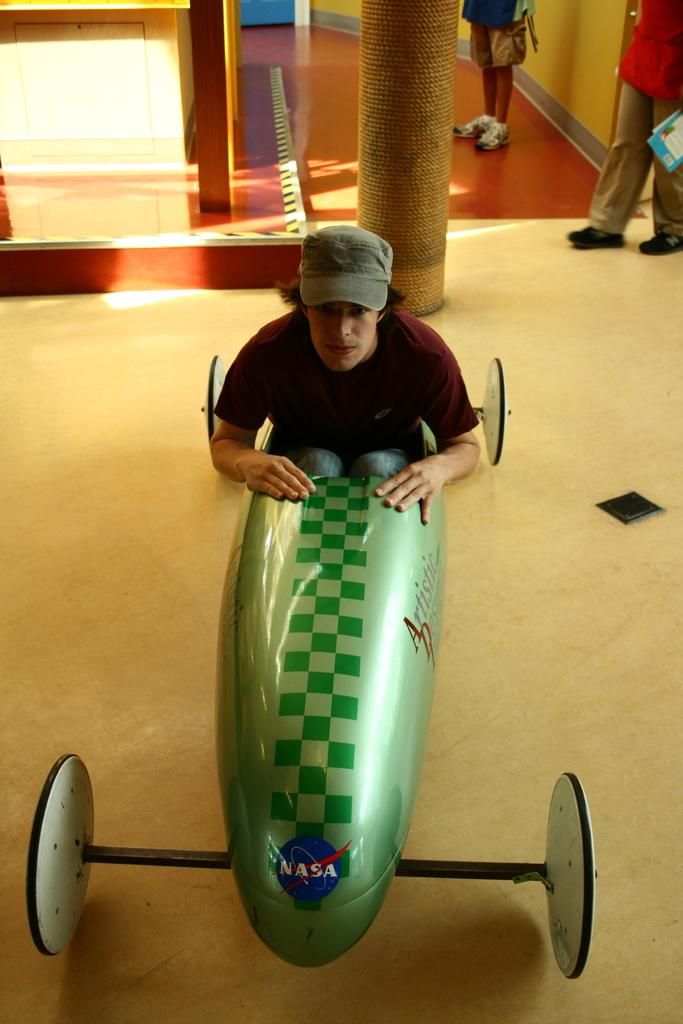<image>
Present a compact description of the photo's key features. Man in a NASA car roaming around with people looking on. 